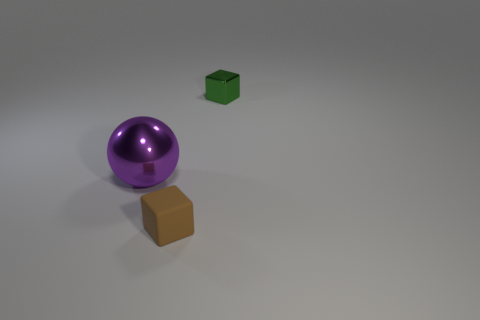Do the shiny block and the brown matte block have the same size?
Provide a succinct answer. Yes. There is a thing that is both on the left side of the small metallic object and on the right side of the large shiny object; what is its color?
Keep it short and to the point. Brown. The purple object has what size?
Offer a terse response. Large. Does the object that is in front of the purple metal thing have the same color as the big object?
Your answer should be compact. No. Are there more small blocks that are in front of the green cube than large things in front of the big sphere?
Give a very brief answer. Yes. Are there more purple metal balls than cubes?
Give a very brief answer. No. What size is the thing that is both behind the matte cube and right of the shiny ball?
Your answer should be compact. Small. What shape is the large shiny object?
Your answer should be compact. Sphere. Is there anything else that has the same size as the metallic sphere?
Your answer should be very brief. No. Is the number of tiny green metallic blocks that are on the right side of the tiny brown rubber thing greater than the number of big purple rubber cylinders?
Make the answer very short. Yes. 